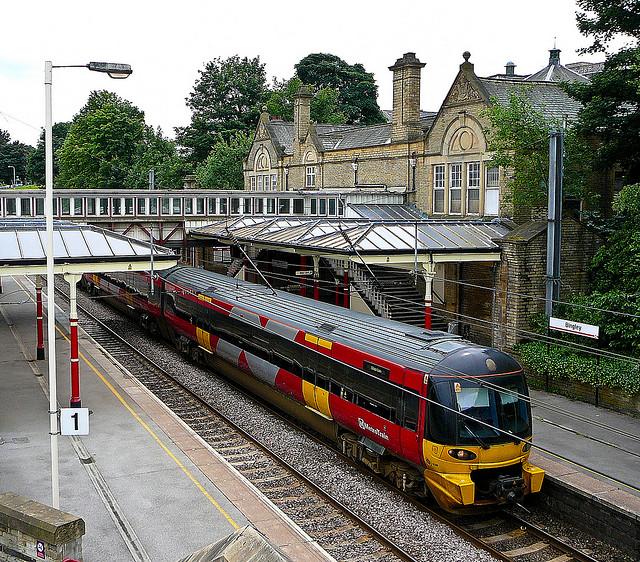Where is platform number 1?
Give a very brief answer. Left. What letter is on the train?
Keep it brief. N. Can the train move to the right?
Give a very brief answer. No. Is the train moving through a city?
Answer briefly. Yes. What colors are on the train?
Answer briefly. Red and yellow. 